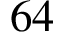<formula> <loc_0><loc_0><loc_500><loc_500>6 4</formula> 